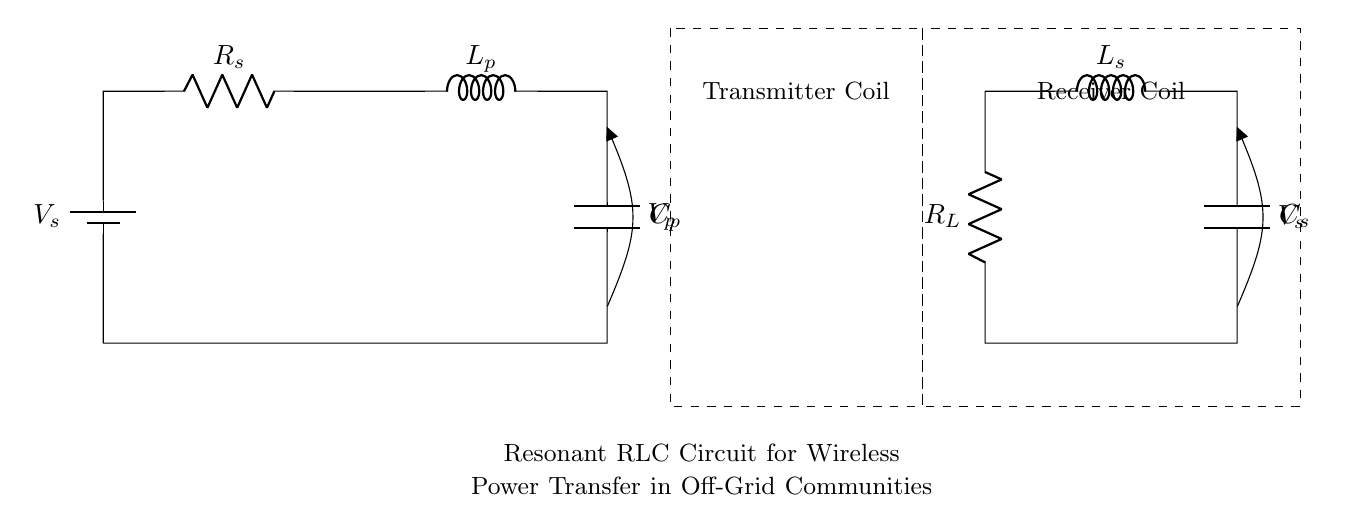What are the main components in this circuit? The circuit contains a battery, resistor, inductor, and capacitor. Each symbol represents one of these components according to the standard notation used in electrical diagrams.
Answer: battery, resistor, inductor, capacitor What is the purpose of the transmitter coil? The transmitter coil is designed to create an electromagnetic field when current flows through it, enabling wireless power transfer. This is denoted by the dashed rectangle labeled "Transmitter Coil" in the diagram.
Answer: enable wireless power transfer What is connected to the output of the receiver coil? The output of the receiver coil connects to a resistor denoted as R_L, which represents the load in this circuit. The load consumes the power transferred wirelessly.
Answer: R_L What are the values represented by V_s and V_p in this circuit? V_s is the voltage provided by the battery (source voltage), and V_p is the voltage across the primary circuit components defined within the transmitter section.
Answer: source voltage, voltage across primary How does the resonant frequency relate to this RLC circuit? The resonant frequency of an RLC circuit is determined by the values of the inductor and capacitor. It occurs when the inductive reactance equals the capacitive reactance, maximizing power transfer. In this case, specific values for L_p and C_p would be necessary for calculation.
Answer: maximizes power transfer What is the role of the capacitor in power transfer? The capacitor in this RLC circuit is essential for tuning the circuit to resonate at a specific frequency, facilitating efficient wireless power transfer between the transmitter and receiver coils.
Answer: facilitate efficient power transfer 